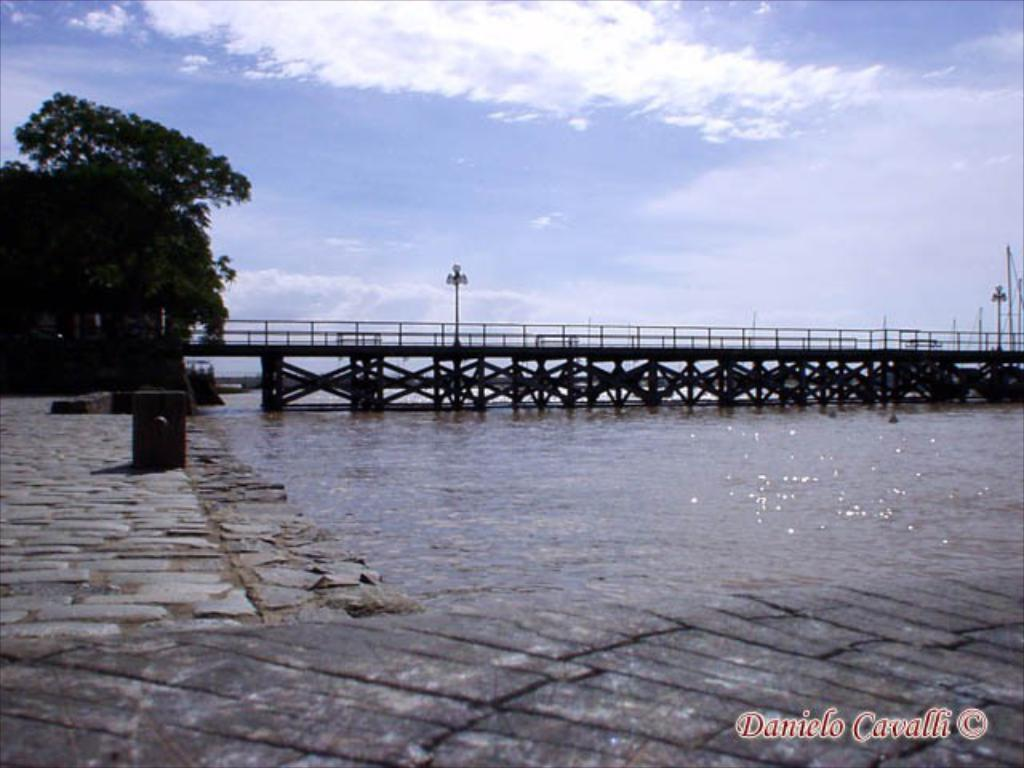What type of structure can be seen in the image? There is a bridge in the image. What else is present in the image besides the bridge? There is a pole, a tree, and water visible in the image. Can you describe the sky in the image? The sky is cloudy in the image. What natural element is present in the image? There is a tree in the image. How many tomatoes are hanging from the bridge in the image? There are no tomatoes present in the image; it features a bridge, a pole, a tree, water, and a cloudy sky. What type of plot is being used to grow the tomatoes in the image? There are no tomatoes or plots present in the image. 